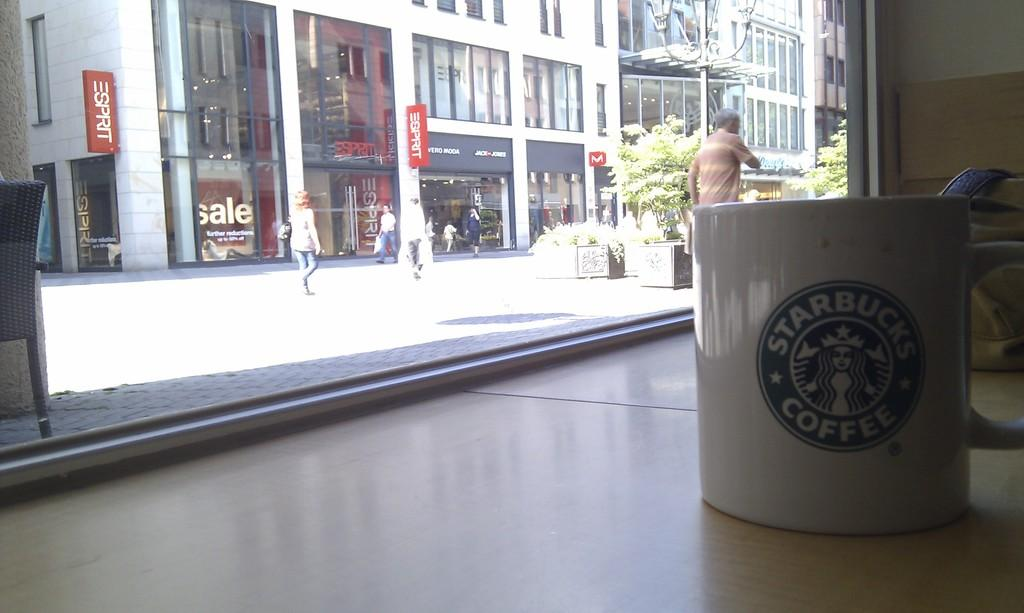Provide a one-sentence caption for the provided image. White cup with a starbucks coffee logo in green and white. 